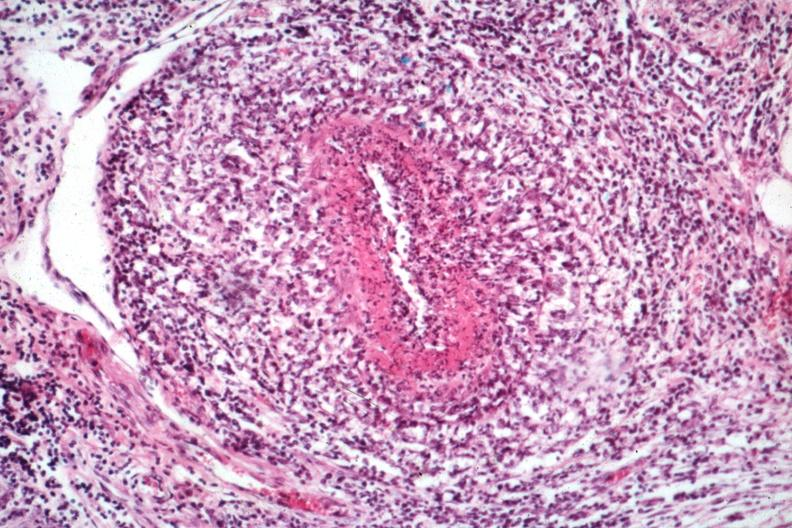s rheumatoid arthritis with vasculitis present?
Answer the question using a single word or phrase. Yes 